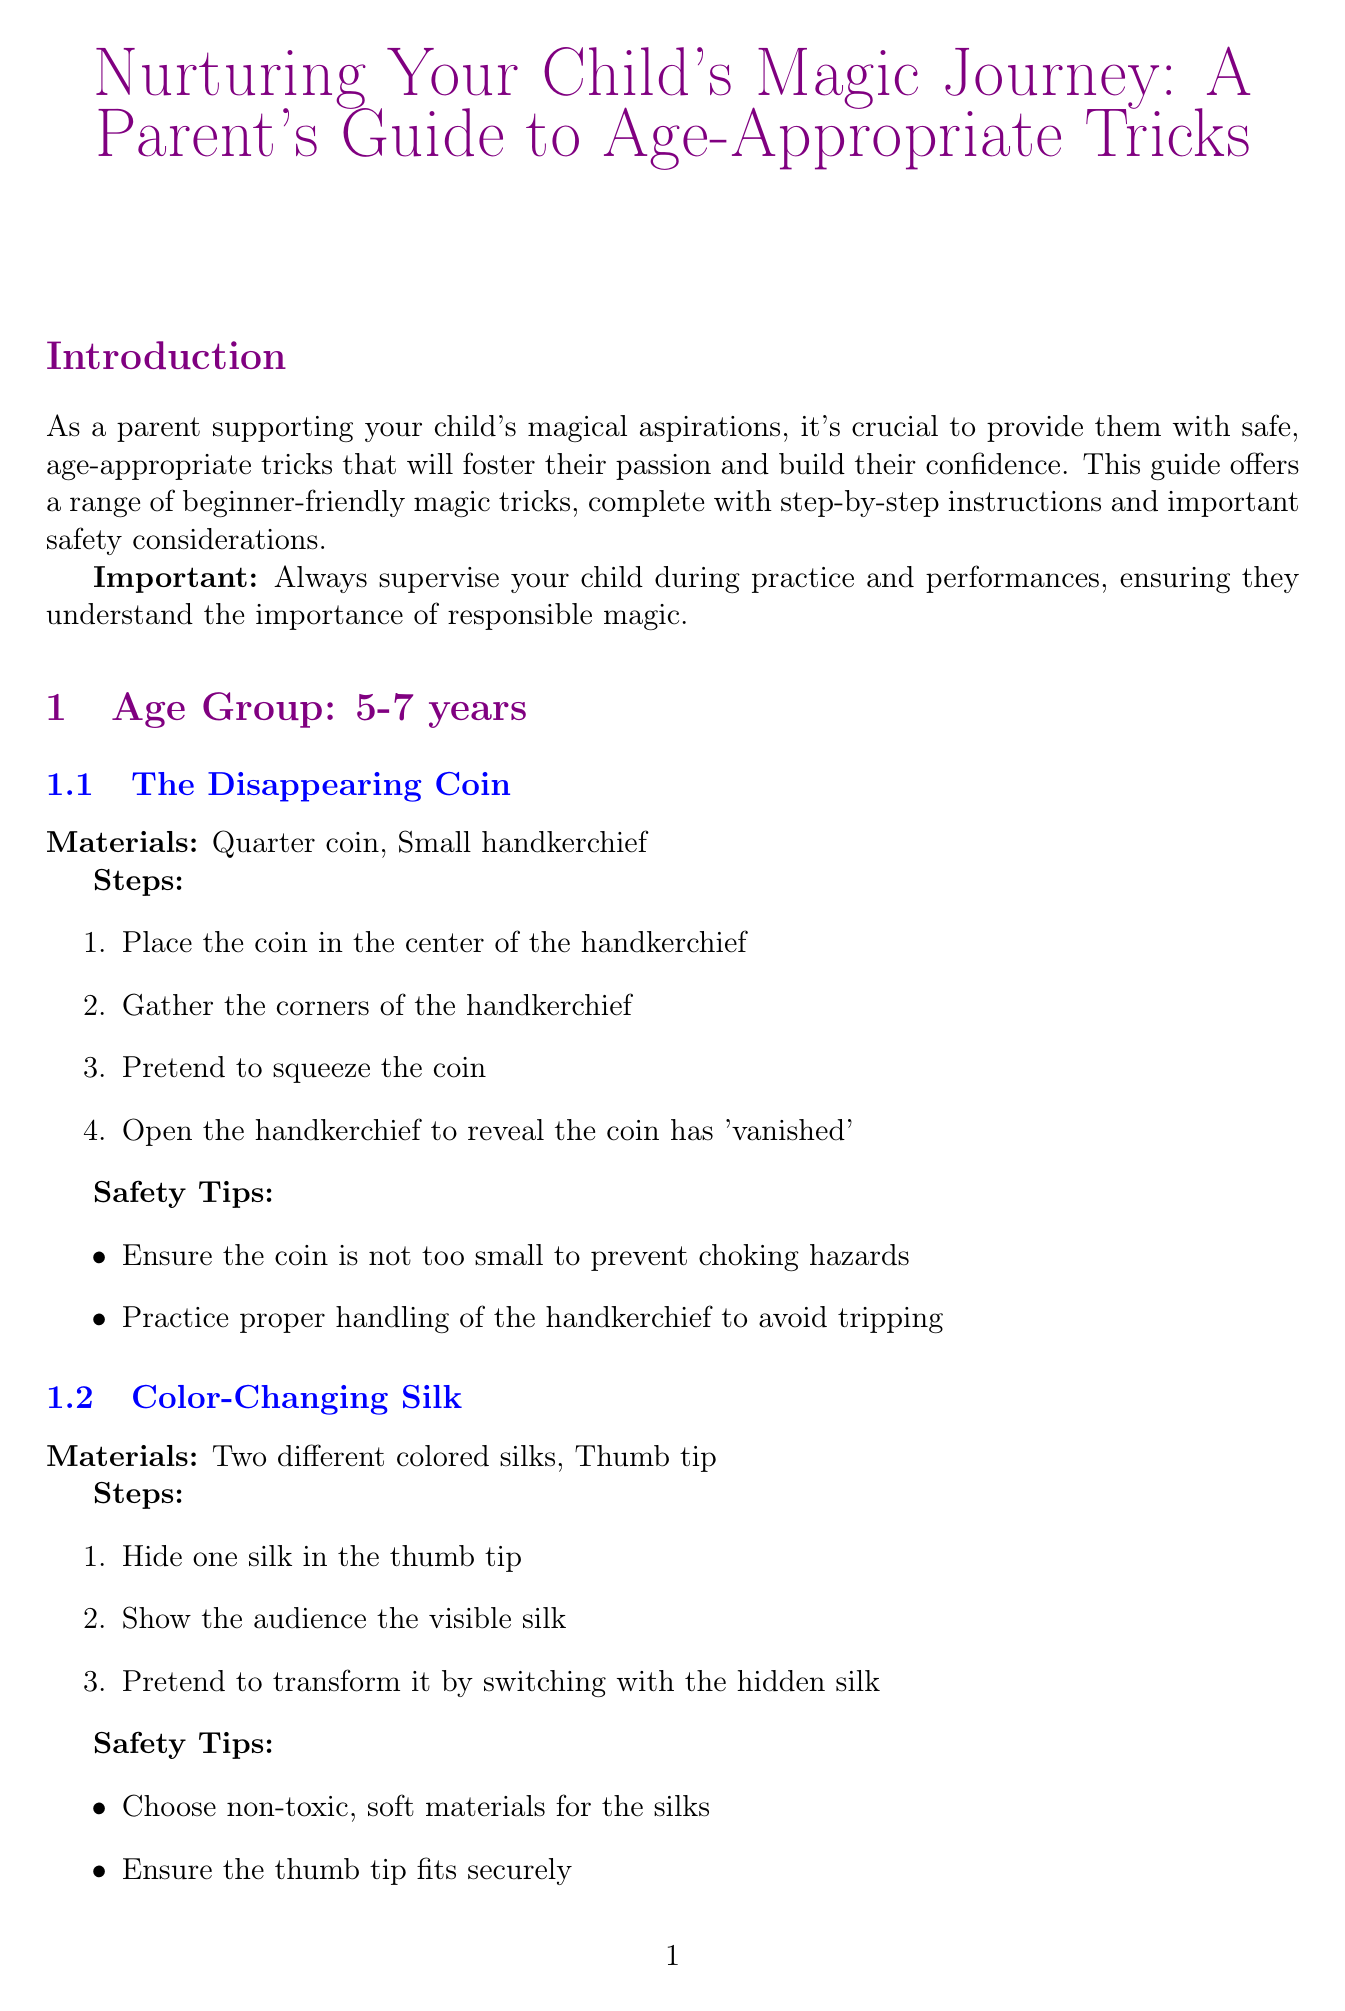what is the title of the guide? The title is listed at the beginning of the document.
Answer: Nurturing Your Child's Magic Journey: A Parent's Guide to Age-Appropriate Tricks what is the age range for the first set of tricks? The document specifies different age groups with corresponding tricks.
Answer: 5-7 years how many tricks are listed for the age group 8-10 years? The document details the number of tricks available in each age group.
Answer: 2 what is one material used in The Disappearing Coin trick? The document provides specific materials required for each trick.
Answer: Quarter coin what safety tip is associated with the Color-Changing Silk trick? The document mentions safety tips specific to tricks, showing the need for careful handling.
Answer: Choose non-toxic, soft materials for the silks what should always be practiced before performing? The document provides general safety guidelines for magic practice.
Answer: Tricks mention a resource for young magicians. The document lists multiple resources that can aid young magicians.
Answer: International Brotherhood of Magicians Youth Program how many sections are there specifically about age groups? The document organizes tricks by age group, reflecting the structure.
Answer: 3 what is one way to encourage creativity in magic? The document suggests methods for supporting children in their magic journey.
Answer: Help them develop unique presentations 